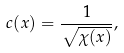<formula> <loc_0><loc_0><loc_500><loc_500>c ( x ) = \frac { 1 } { \sqrt { \chi ( x ) } } ,</formula> 